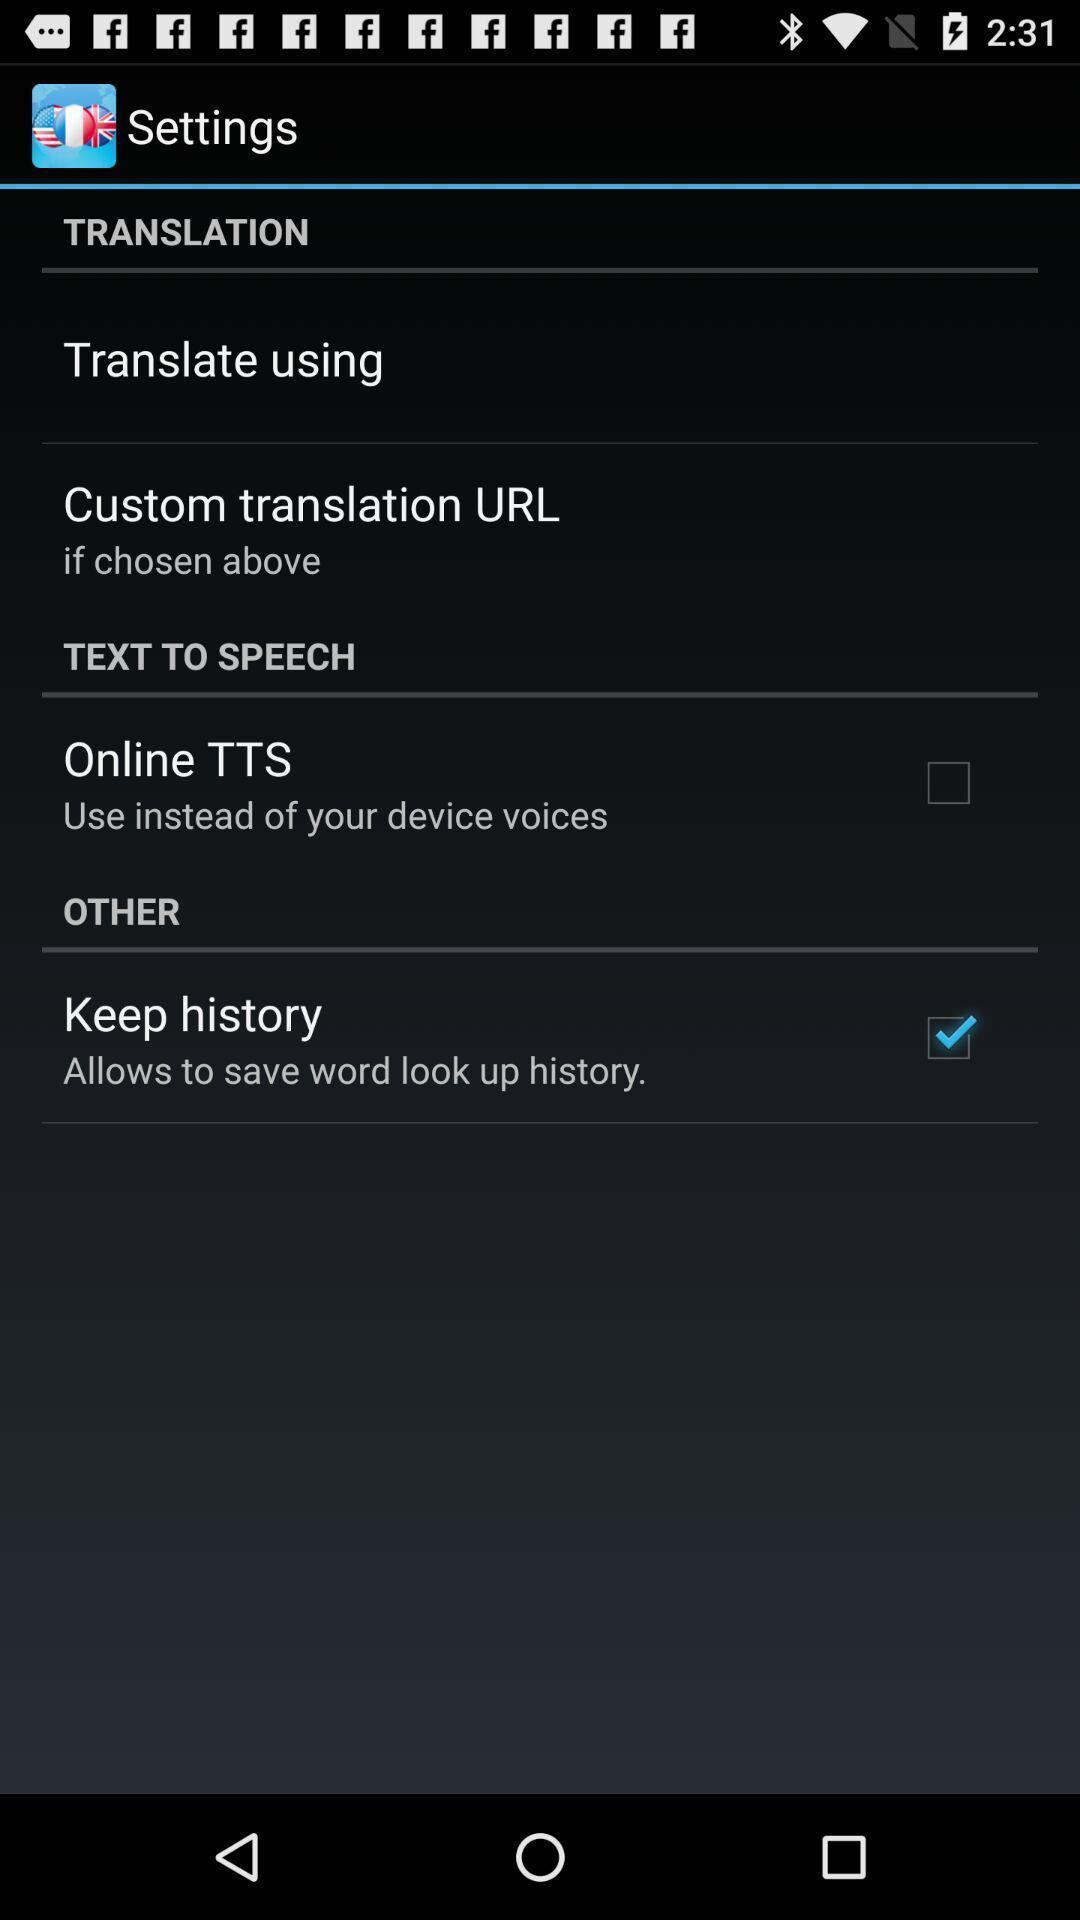What is the overall content of this screenshot? Screen showing settings page. 